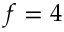<formula> <loc_0><loc_0><loc_500><loc_500>f = 4</formula> 